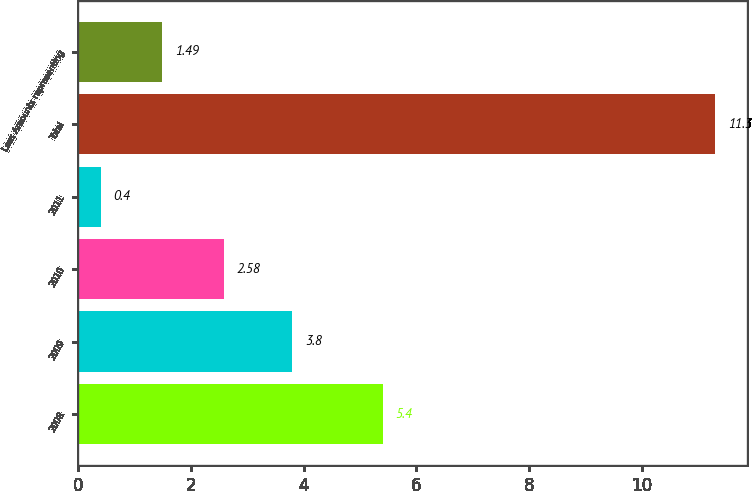<chart> <loc_0><loc_0><loc_500><loc_500><bar_chart><fcel>2008<fcel>2009<fcel>2010<fcel>2011<fcel>Total<fcel>Less Amounts representing<nl><fcel>5.4<fcel>3.8<fcel>2.58<fcel>0.4<fcel>11.3<fcel>1.49<nl></chart> 